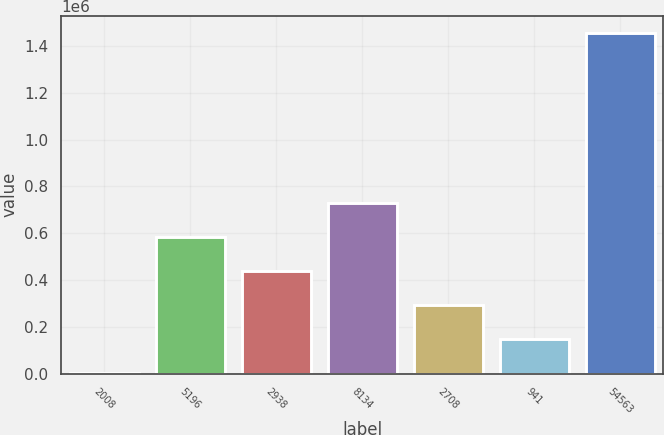Convert chart. <chart><loc_0><loc_0><loc_500><loc_500><bar_chart><fcel>2008<fcel>5196<fcel>2938<fcel>8134<fcel>2708<fcel>941<fcel>54563<nl><fcel>2007<fcel>583222<fcel>437918<fcel>728526<fcel>292614<fcel>147311<fcel>1.45504e+06<nl></chart> 